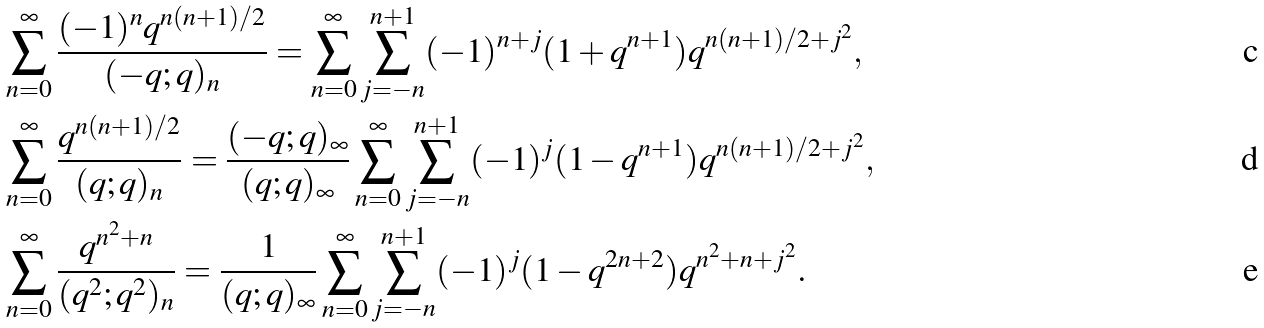Convert formula to latex. <formula><loc_0><loc_0><loc_500><loc_500>& \sum _ { n = 0 } ^ { \infty } \frac { ( - 1 ) ^ { n } q ^ { n ( n + 1 ) / 2 } } { ( - q ; q ) _ { n } } = \sum _ { n = 0 } ^ { \infty } \sum _ { j = - n } ^ { n + 1 } ( - 1 ) ^ { n + j } ( 1 + q ^ { n + 1 } ) q ^ { n ( n + 1 ) / 2 + j ^ { 2 } } , \\ & \sum _ { n = 0 } ^ { \infty } \frac { q ^ { n ( n + 1 ) / 2 } } { ( q ; q ) _ { n } } = \frac { ( - q ; q ) _ { \infty } } { ( q ; q ) _ { \infty } } \sum _ { n = 0 } ^ { \infty } \sum _ { j = - n } ^ { n + 1 } ( - 1 ) ^ { j } ( 1 - q ^ { n + 1 } ) q ^ { n ( n + 1 ) / 2 + j ^ { 2 } } , \\ & \sum _ { n = 0 } ^ { \infty } \frac { q ^ { n ^ { 2 } + n } } { ( q ^ { 2 } ; q ^ { 2 } ) _ { n } } = \frac { 1 } { ( q ; q ) _ { \infty } } \sum _ { n = 0 } ^ { \infty } \sum _ { j = - n } ^ { n + 1 } ( - 1 ) ^ { j } ( 1 - q ^ { 2 n + 2 } ) q ^ { n ^ { 2 } + n + j ^ { 2 } } .</formula> 